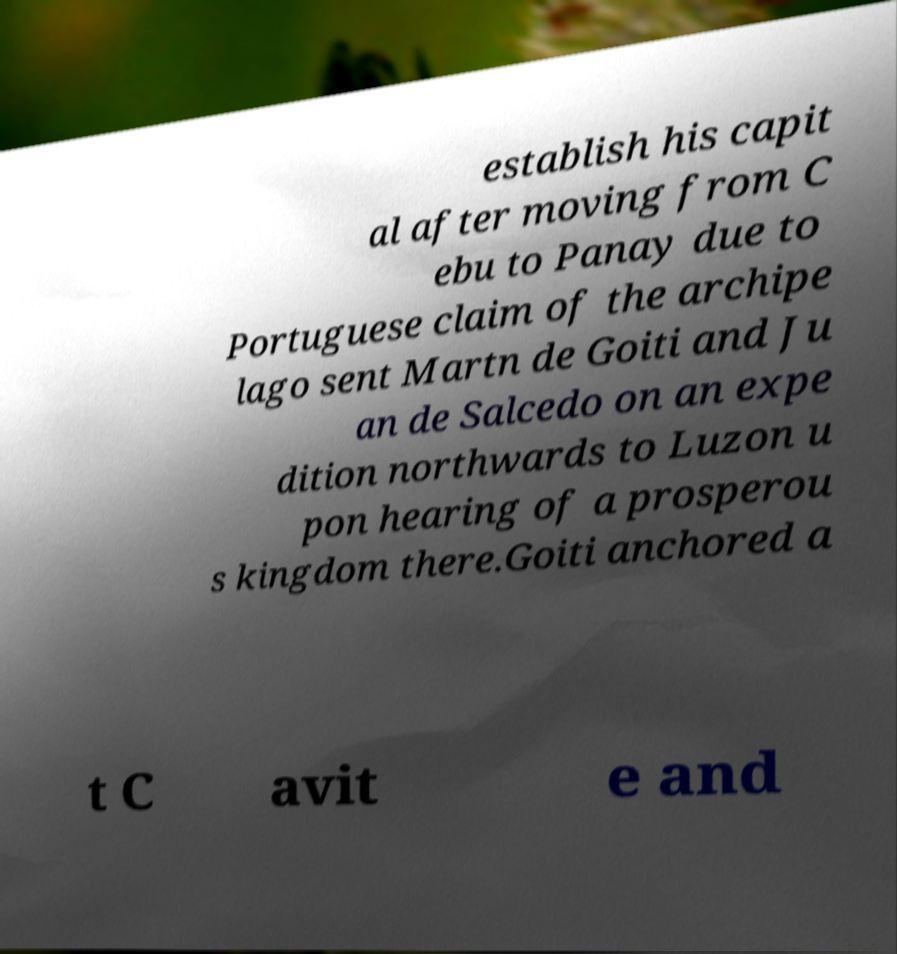For documentation purposes, I need the text within this image transcribed. Could you provide that? establish his capit al after moving from C ebu to Panay due to Portuguese claim of the archipe lago sent Martn de Goiti and Ju an de Salcedo on an expe dition northwards to Luzon u pon hearing of a prosperou s kingdom there.Goiti anchored a t C avit e and 